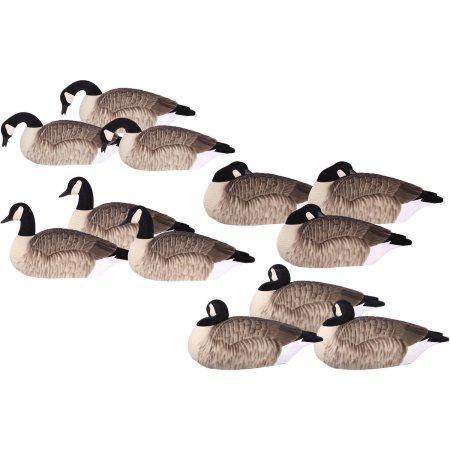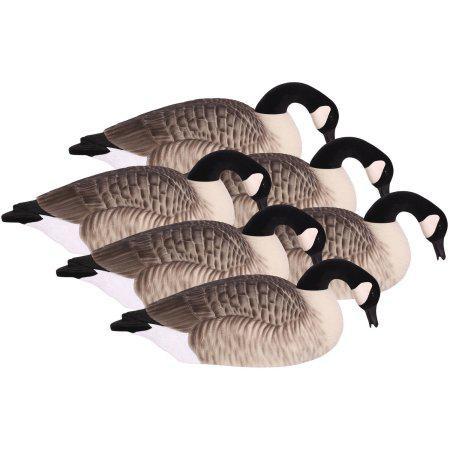The first image is the image on the left, the second image is the image on the right. Analyze the images presented: Is the assertion "All geese have flat bases without legs, black necks, and folded wings." valid? Answer yes or no. Yes. The first image is the image on the left, the second image is the image on the right. Analyze the images presented: Is the assertion "The geese in one image have dark orange beaks." valid? Answer yes or no. No. 